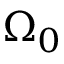Convert formula to latex. <formula><loc_0><loc_0><loc_500><loc_500>\Omega _ { 0 }</formula> 